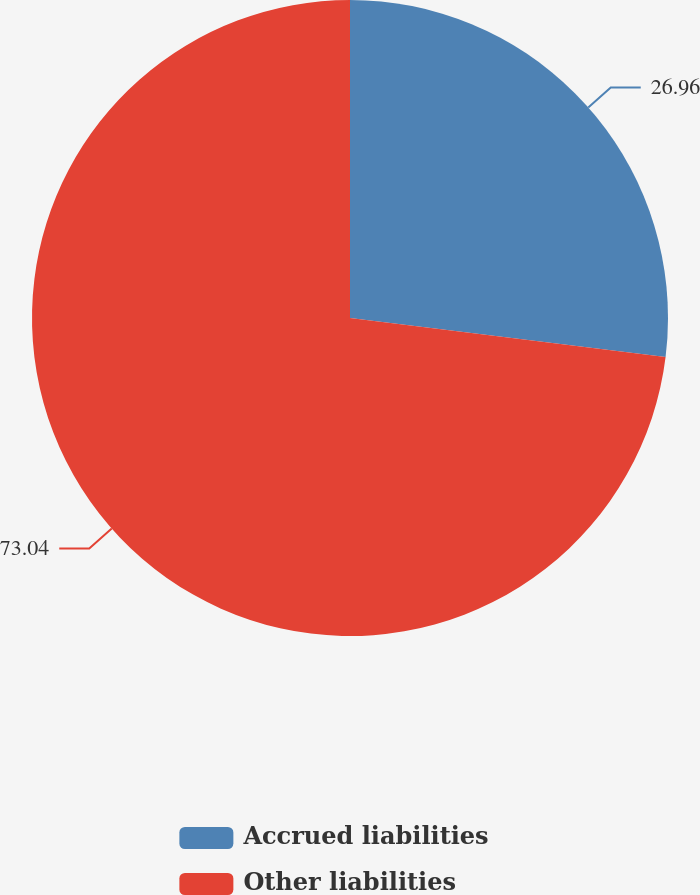<chart> <loc_0><loc_0><loc_500><loc_500><pie_chart><fcel>Accrued liabilities<fcel>Other liabilities<nl><fcel>26.96%<fcel>73.04%<nl></chart> 